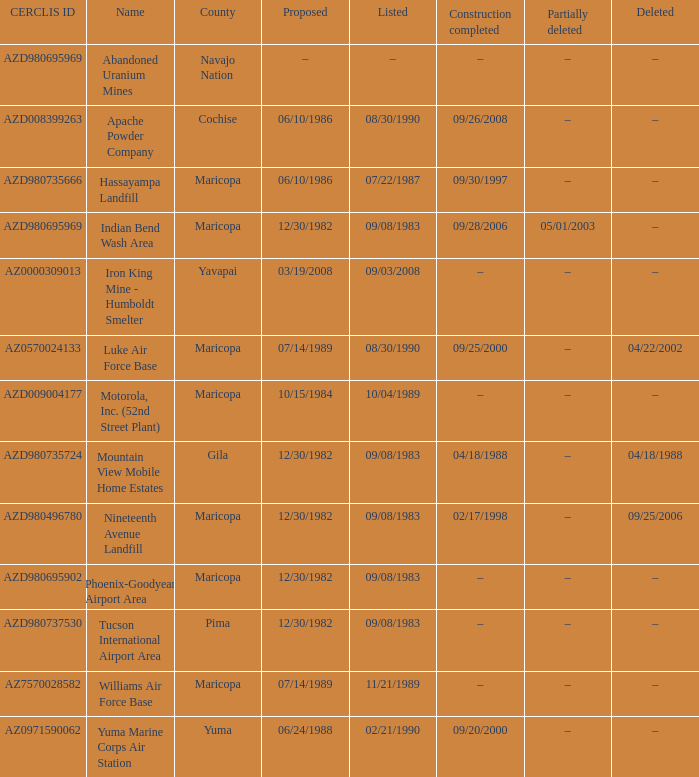When was the location registered when the county is cochise? 08/30/1990. 